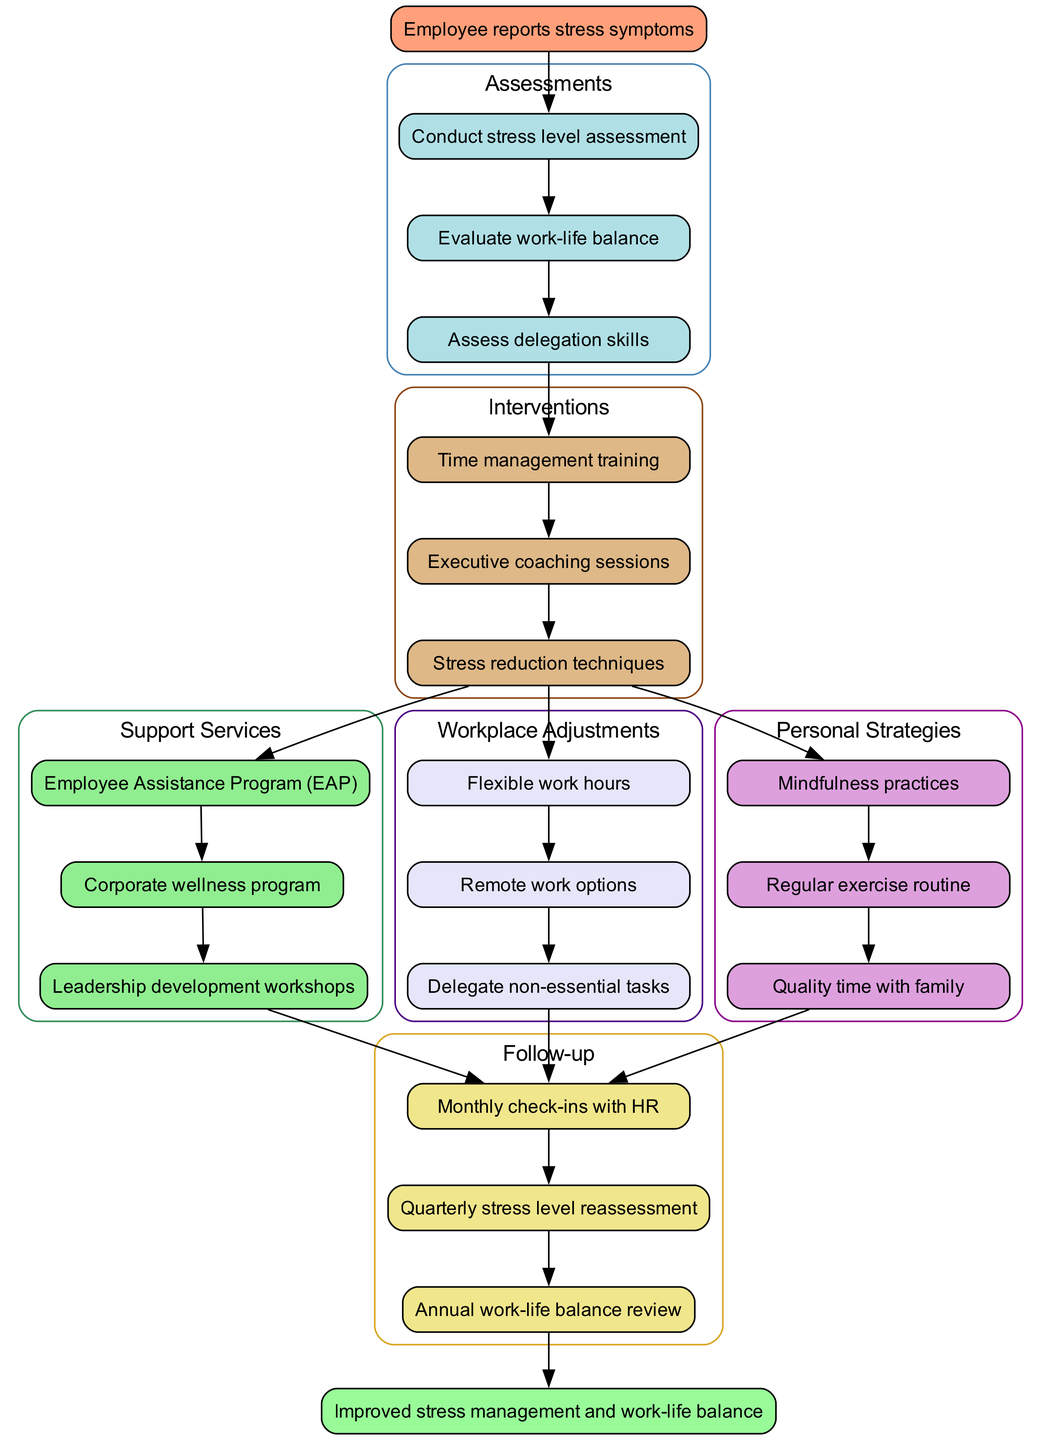What is the starting point of the clinical pathway? The starting point of the clinical pathway is clearly labeled as "Employee reports stress symptoms" in the diagram.
Answer: Employee reports stress symptoms How many assessments are included in the diagram? To find the number of assessments, we can count each item listed under the "Assessments" cluster, which includes three assessments.
Answer: 3 What is the last intervention in the pathway? By examining the "Interventions" cluster, the last intervention listed is "Stress reduction techniques."
Answer: Stress reduction techniques Which support service follows the last intervention? The diagram shows an arrow leading from the last intervention, "Stress reduction techniques," to the first support service, which is "Employee Assistance Program (EAP)."
Answer: Employee Assistance Program (EAP) What is the endpoint of this clinical pathway? The endpoint of the clinical pathway is labeled as "Improved stress management and work-life balance" at the end of the diagram.
Answer: Improved stress management and work-life balance What personal strategy is first in the list? Looking at the "Personal Strategies" subgraph, the first strategy mentioned is "Mindfulness practices."
Answer: Mindfulness practices How does the clinical pathway address work-life balance? The clinical pathway addresses work-life balance through assessments and interventions, including an evaluation of work-life balance, workplace adjustments, and personal strategies to improve it.
Answer: Through assessments and interventions Which cluster has the most nodes visible in the diagram? By analyzing the clusters in the diagram, the "Assessments" cluster has three nodes, while the other clusters, such as "Interventions" and "Support Services," have fewer; thus "Assessments" has the most.
Answer: Assessments What type of follow-up is scheduled annually? The diagram lists "Annual work-life balance review" as one of the follow-up actions, indicating this type of follow-up is scheduled on an annual basis.
Answer: Annual work-life balance review 